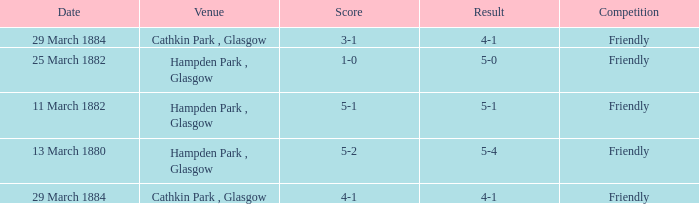Which item has a score of 5-1? 5-1. 